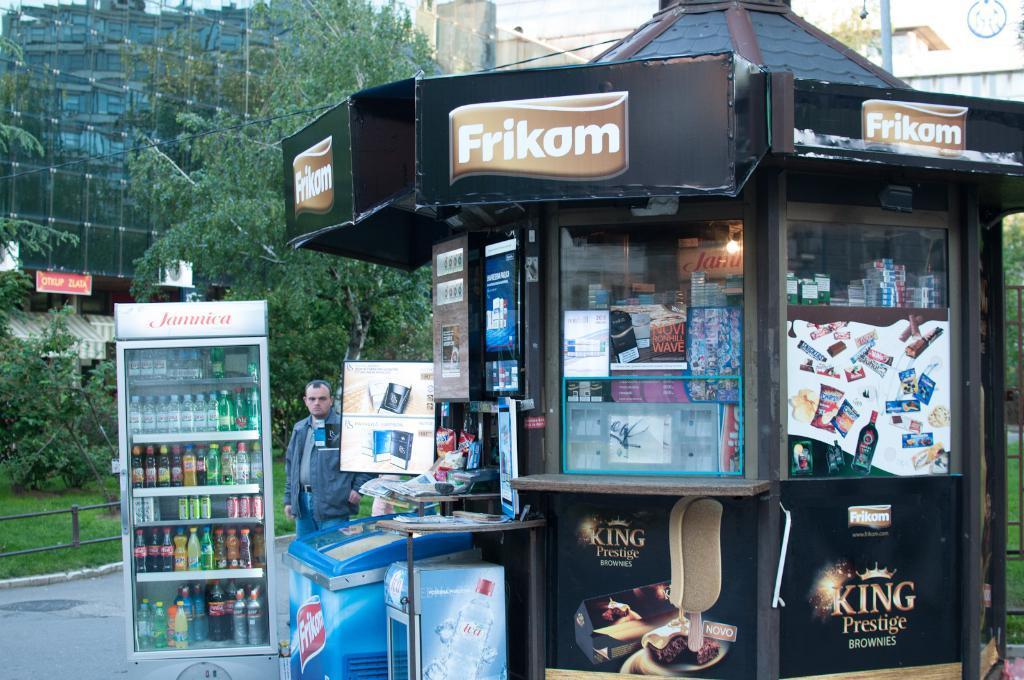Can you describe this image briefly? This picture show that there is a black color cigarette shop. Beside there is a man wearing grey color jacket standing and looking in the camera. Beside there a small refrigerator full of coke and juice bottle. In the back we can see glass building and some trees. 